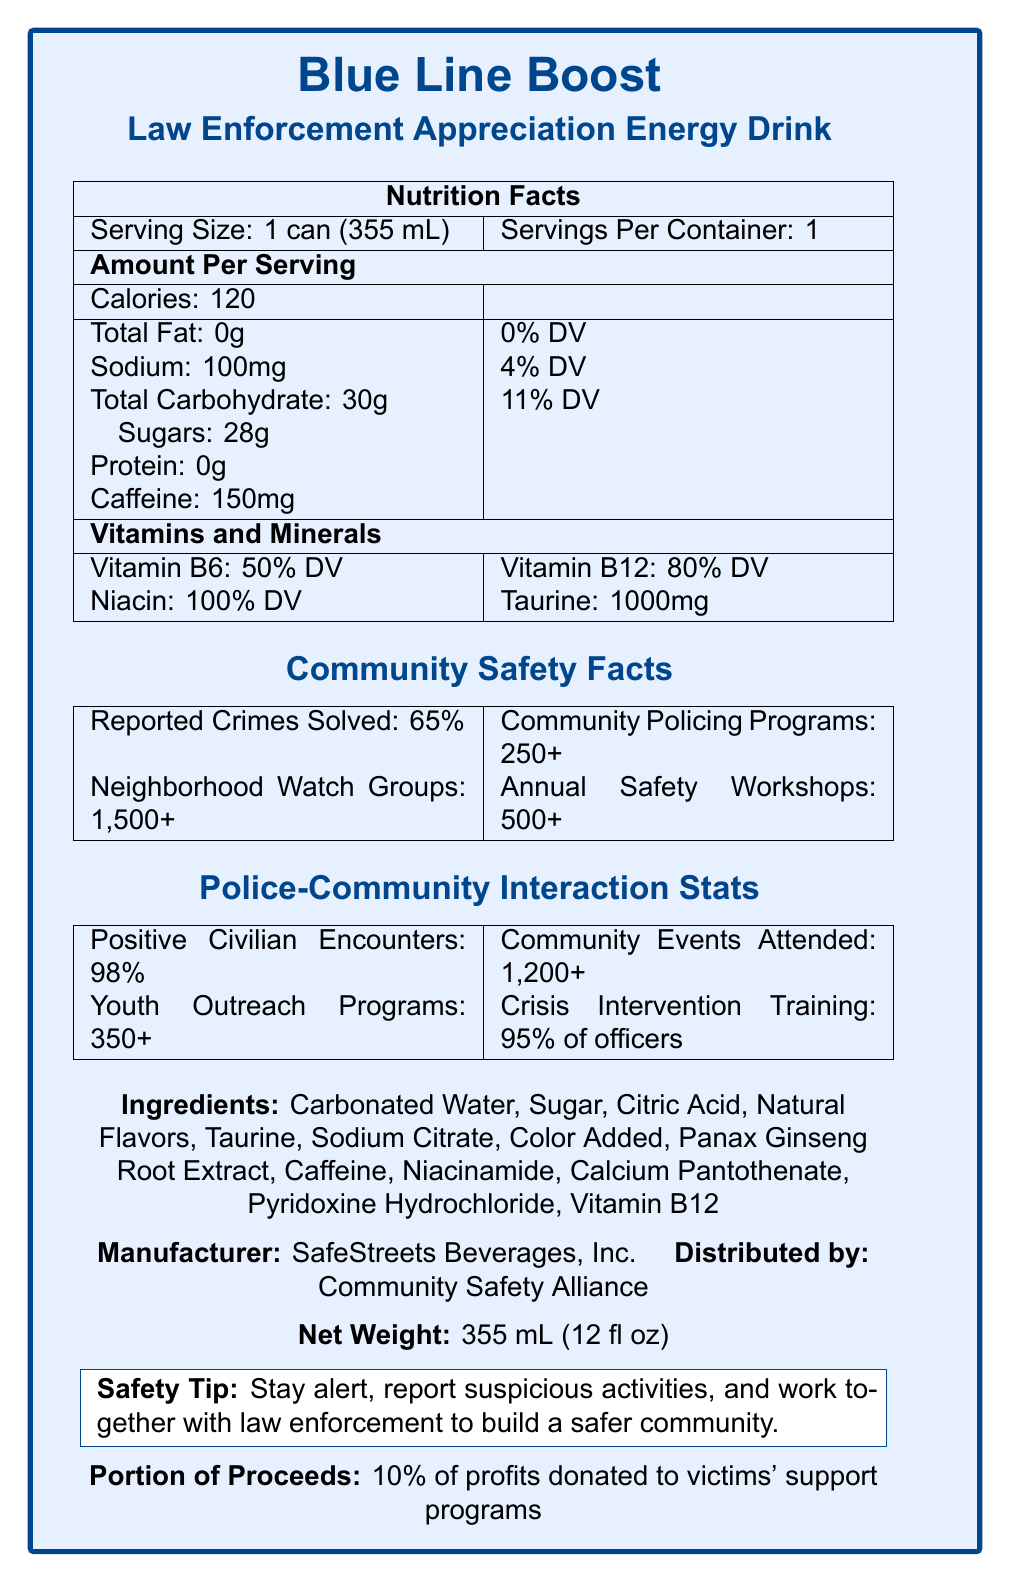What is the serving size for "Blue Line Boost: Law Enforcement Appreciation Energy Drink"? The serving size is indicated at the beginning of the Nutrition Facts section.
Answer: 1 can (355 mL) How many calories are there per serving? The number of calories per serving is listed in the Amount Per Serving section under Nutrition Facts.
Answer: 120 What percentage of Vitamin B12 does one serving provide? The percentage of Vitamin B12 per serving is found under the Vitamins and Minerals section.
Answer: 80% DV How much sodium is in one can of the energy drink? The sodium content is listed under the Amount Per Serving section in the Nutrition Facts.
Answer: 100mg What is the caffeine content in one can? The caffeine content is listed in the Amount Per Serving section.
Answer: 150mg What percentage of proceeds are donated to victims' support programs? This information is stated under the Portion of Proceeds section at the bottom of the document.
Answer: 10% How many reported crimes are solved, according to the Community Safety Facts? A. 50% B. 65% C. 75% The percentage of reported crimes solved is included in the Community Safety Facts section.
Answer: B. 65% Which of the following vitamins or minerals has the highest daily value percentage per serving? A. Vitamin B6 B. Vitamin B12 C. Niacin D. Taurine The Vitamins and Minerals section indicates that Niacin has a 100% daily value per serving.
Answer: C. Niacin The drink's manufacturer is SafeStreets Beverages, Inc. The manufacturer information is provided at the bottom of the document.
Answer: Yes What are some activities included in the Police-Community Interaction Stats? List at least two. These activities are listed in the Police-Community Interaction Stats section.
Answer: Positive Civilian Encounters, Community Events Attended, Youth Outreach Programs, Crisis Intervention Training Summarize the main idea of the document. The summary encompasses all relevant sections of the document, providing a comprehensive overview of the information presented.
Answer: The document is a Nutrition Facts Label for "Blue Line Boost: Law Enforcement Appreciation Energy Drink," celebrating positive police-community interactions. It includes nutritional information, community safety statistics, police-community interaction stats, and additional details about the product's ingredients, manufacturer, and proceeds benefitting victims' support programs. Are there any specific details about the flavor of the drink? The document does not provide any flavor details, only the ingredients and nutritional content.
Answer: Not enough information What is the main purpose of the dietary "Safety Tip" provided? The safety tip at the bottom of the document emphasizes staying alert and working together with law enforcement.
Answer: To encourage vigilance and cooperation with law enforcement to build a safer community 